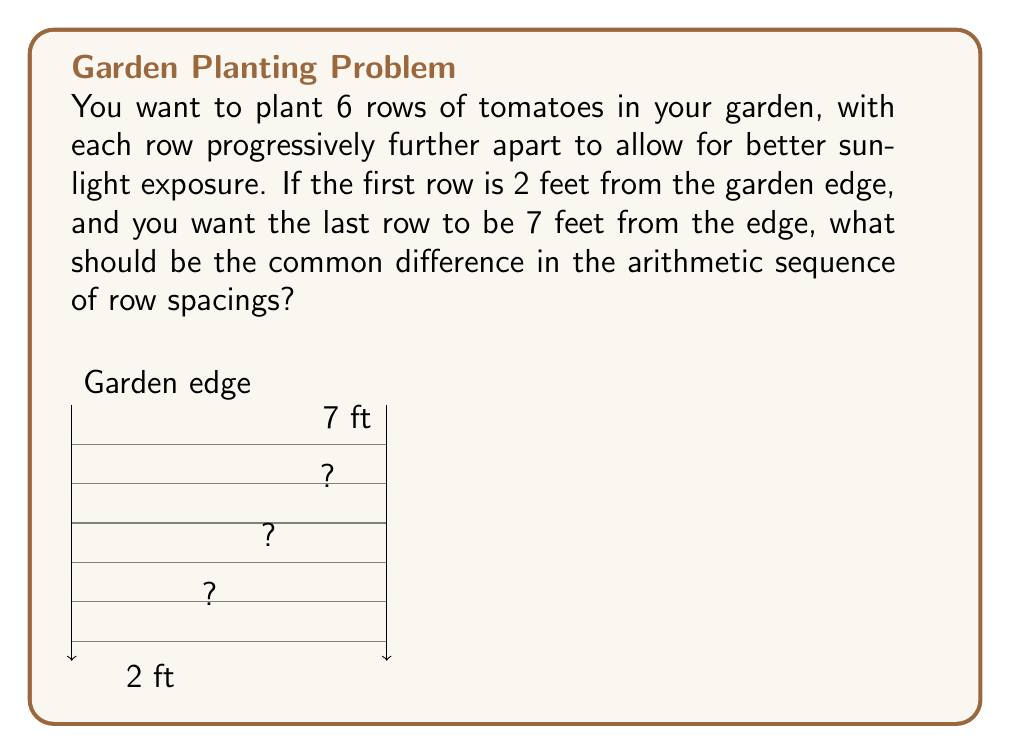What is the answer to this math problem? Let's approach this step-by-step:

1) We're dealing with an arithmetic sequence where:
   - The first term $a_1 = 2$ (2 feet from the edge)
   - The last term $a_6 = 7$ (7 feet from the edge)
   - We need to find the common difference $d$

2) In an arithmetic sequence, the nth term is given by:
   $a_n = a_1 + (n-1)d$

3) We can use this to set up an equation for the last term:
   $a_6 = a_1 + (6-1)d$
   $7 = 2 + 5d$

4) Now we can solve for $d$:
   $7 - 2 = 5d$
   $5 = 5d$
   $d = 1$

5) To verify, let's check the sequence:
   $a_1 = 2$
   $a_2 = 2 + 1 = 3$
   $a_3 = 3 + 1 = 4$
   $a_4 = 4 + 1 = 5$
   $a_5 = 5 + 1 = 6$
   $a_6 = 6 + 1 = 7$

This sequence satisfies our conditions, with the first row at 2 feet and the last row at 7 feet.
Answer: $1$ foot 